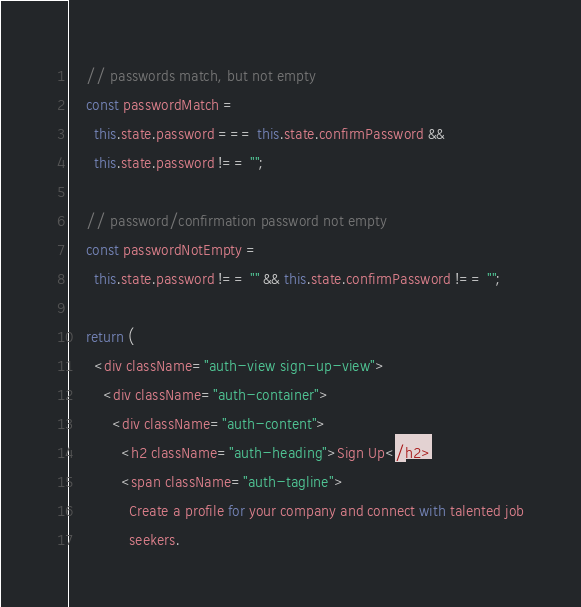<code> <loc_0><loc_0><loc_500><loc_500><_JavaScript_>    // passwords match, but not empty
    const passwordMatch =
      this.state.password === this.state.confirmPassword &&
      this.state.password !== "";

    // password/confirmation password not empty
    const passwordNotEmpty =
      this.state.password !== "" && this.state.confirmPassword !== "";

    return (
      <div className="auth-view sign-up-view">
        <div className="auth-container">
          <div className="auth-content">
            <h2 className="auth-heading">Sign Up</h2>
            <span className="auth-tagline">
              Create a profile for your company and connect with talented job
              seekers.</code> 